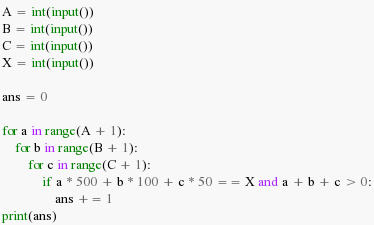Convert code to text. <code><loc_0><loc_0><loc_500><loc_500><_Python_>A = int(input())
B = int(input())
C = int(input())
X = int(input())

ans = 0

for a in range(A + 1):
    for b in range(B + 1):
        for c in range(C + 1):
            if a * 500 + b * 100 + c * 50 == X and a + b + c > 0:
                ans += 1
print(ans)</code> 